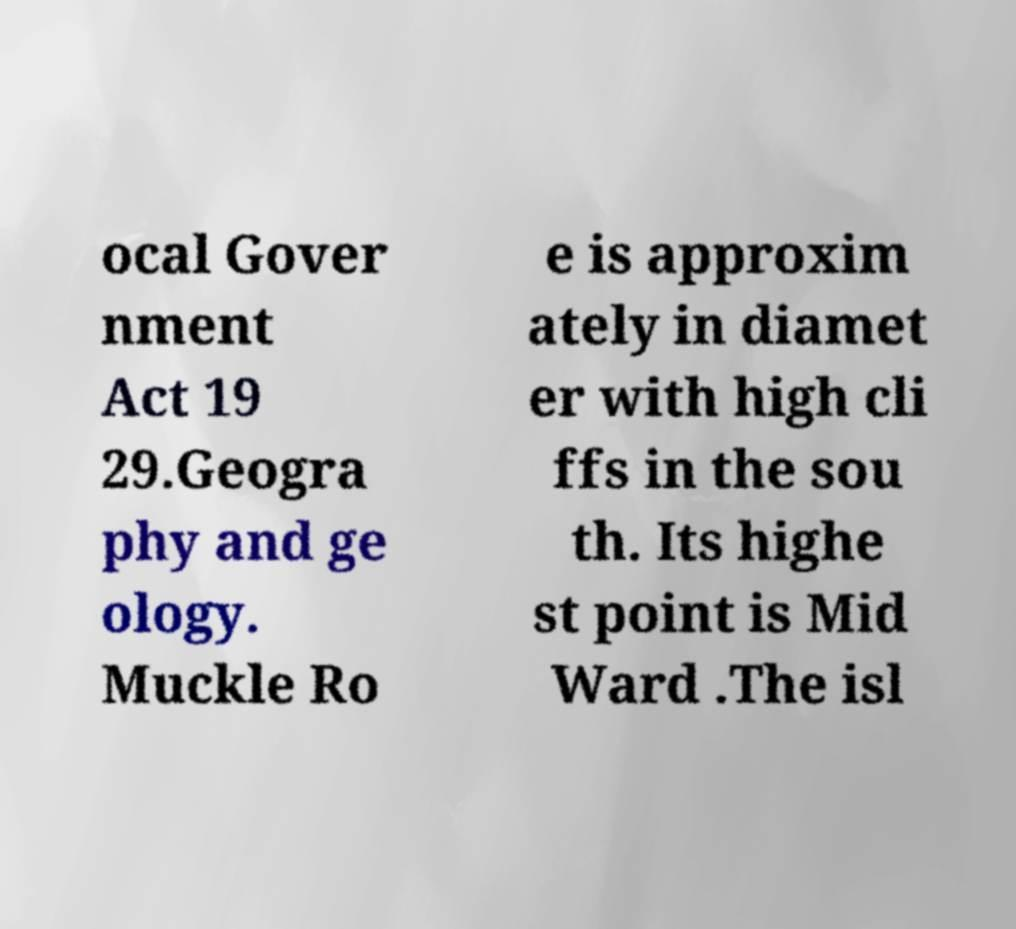Please identify and transcribe the text found in this image. ocal Gover nment Act 19 29.Geogra phy and ge ology. Muckle Ro e is approxim ately in diamet er with high cli ffs in the sou th. Its highe st point is Mid Ward .The isl 